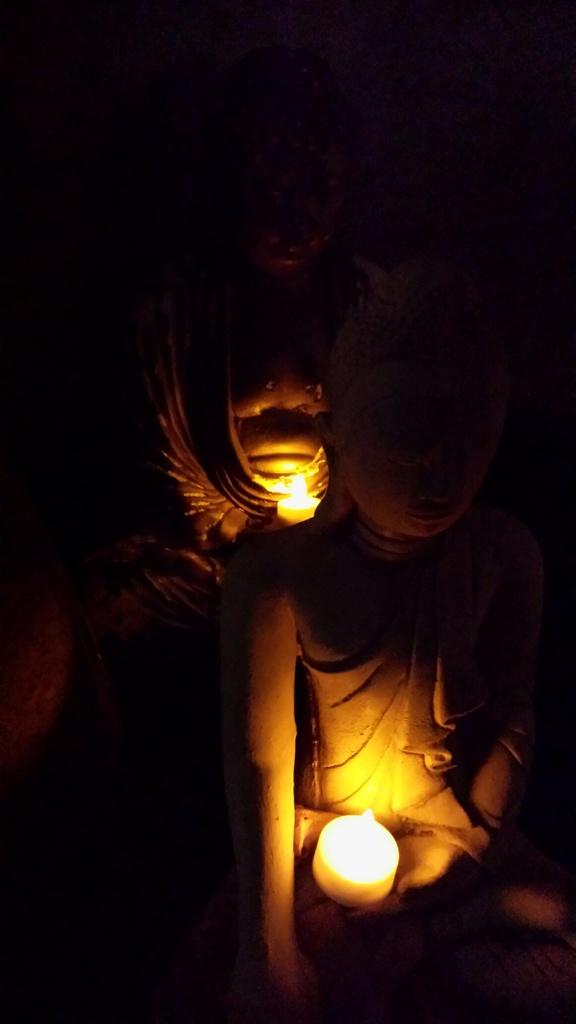What is depicted in the image? There are two person idols in the image. Are there any additional elements associated with the idols? Yes, the idols have candles on them. How many children are holding bananas in the image? There are no children or bananas present in the image. What type of rhythm can be heard coming from the idols in the image? There is no sound or rhythm associated with the idols in the image. 